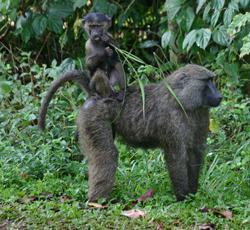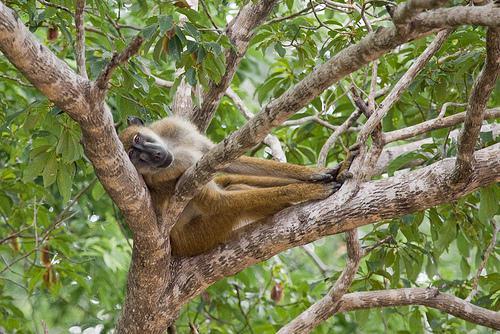The first image is the image on the left, the second image is the image on the right. For the images displayed, is the sentence "One of these lesser apes is carrying a younger primate." factually correct? Answer yes or no. Yes. The first image is the image on the left, the second image is the image on the right. Examine the images to the left and right. Is the description "a baby baboon is riding on its mothers back" accurate? Answer yes or no. Yes. 